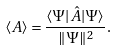<formula> <loc_0><loc_0><loc_500><loc_500>\langle A \rangle = \frac { \langle \Psi | { \hat { A } } | \Psi \rangle } { \| \Psi \| ^ { 2 } } .</formula> 